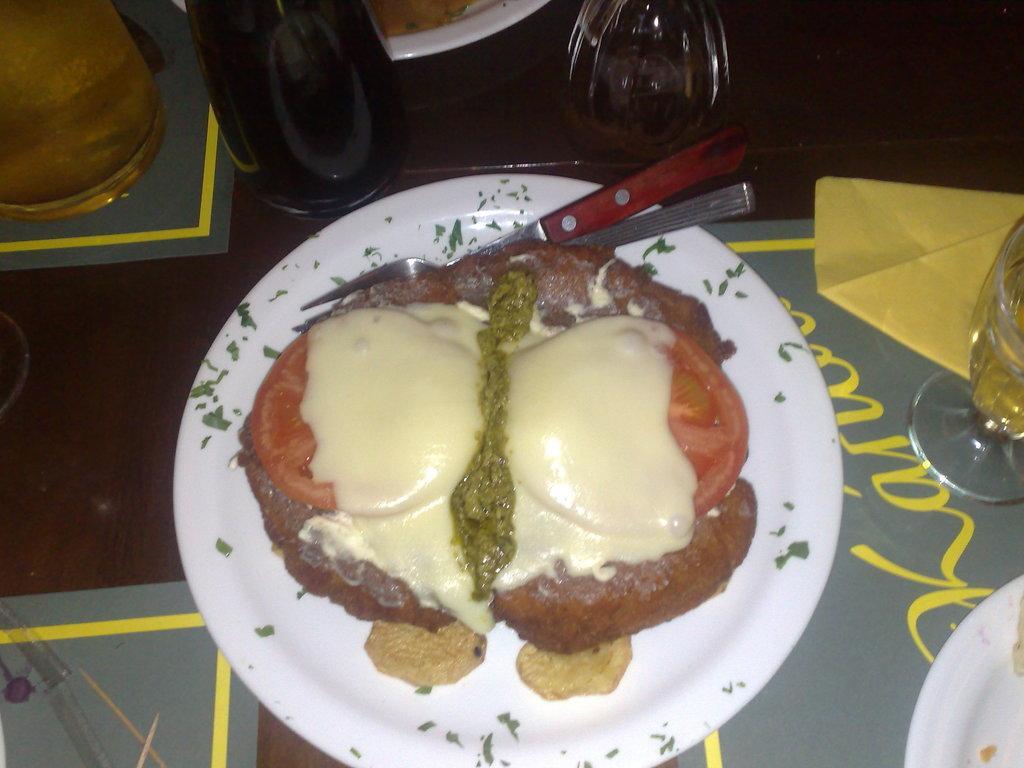How would you summarize this image in a sentence or two? In the middle of the image there is a plate with a food item, a fork and a knife on the plate. At the bottom of the image there is a table with a few papers, a glass of wine, a plate, a bottle, a glass of water and a glass of juice on it. 